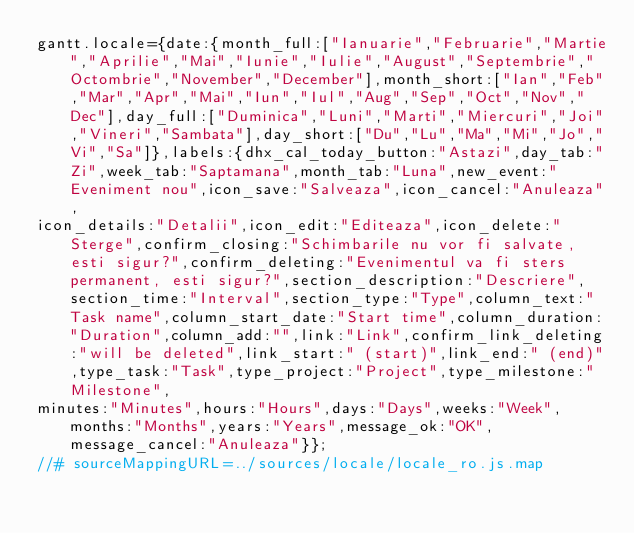<code> <loc_0><loc_0><loc_500><loc_500><_JavaScript_>gantt.locale={date:{month_full:["Ianuarie","Februarie","Martie","Aprilie","Mai","Iunie","Iulie","August","Septembrie","Octombrie","November","December"],month_short:["Ian","Feb","Mar","Apr","Mai","Iun","Iul","Aug","Sep","Oct","Nov","Dec"],day_full:["Duminica","Luni","Marti","Miercuri","Joi","Vineri","Sambata"],day_short:["Du","Lu","Ma","Mi","Jo","Vi","Sa"]},labels:{dhx_cal_today_button:"Astazi",day_tab:"Zi",week_tab:"Saptamana",month_tab:"Luna",new_event:"Eveniment nou",icon_save:"Salveaza",icon_cancel:"Anuleaza",
icon_details:"Detalii",icon_edit:"Editeaza",icon_delete:"Sterge",confirm_closing:"Schimbarile nu vor fi salvate, esti sigur?",confirm_deleting:"Evenimentul va fi sters permanent, esti sigur?",section_description:"Descriere",section_time:"Interval",section_type:"Type",column_text:"Task name",column_start_date:"Start time",column_duration:"Duration",column_add:"",link:"Link",confirm_link_deleting:"will be deleted",link_start:" (start)",link_end:" (end)",type_task:"Task",type_project:"Project",type_milestone:"Milestone",
minutes:"Minutes",hours:"Hours",days:"Days",weeks:"Week",months:"Months",years:"Years",message_ok:"OK",message_cancel:"Anuleaza"}};
//# sourceMappingURL=../sources/locale/locale_ro.js.map</code> 